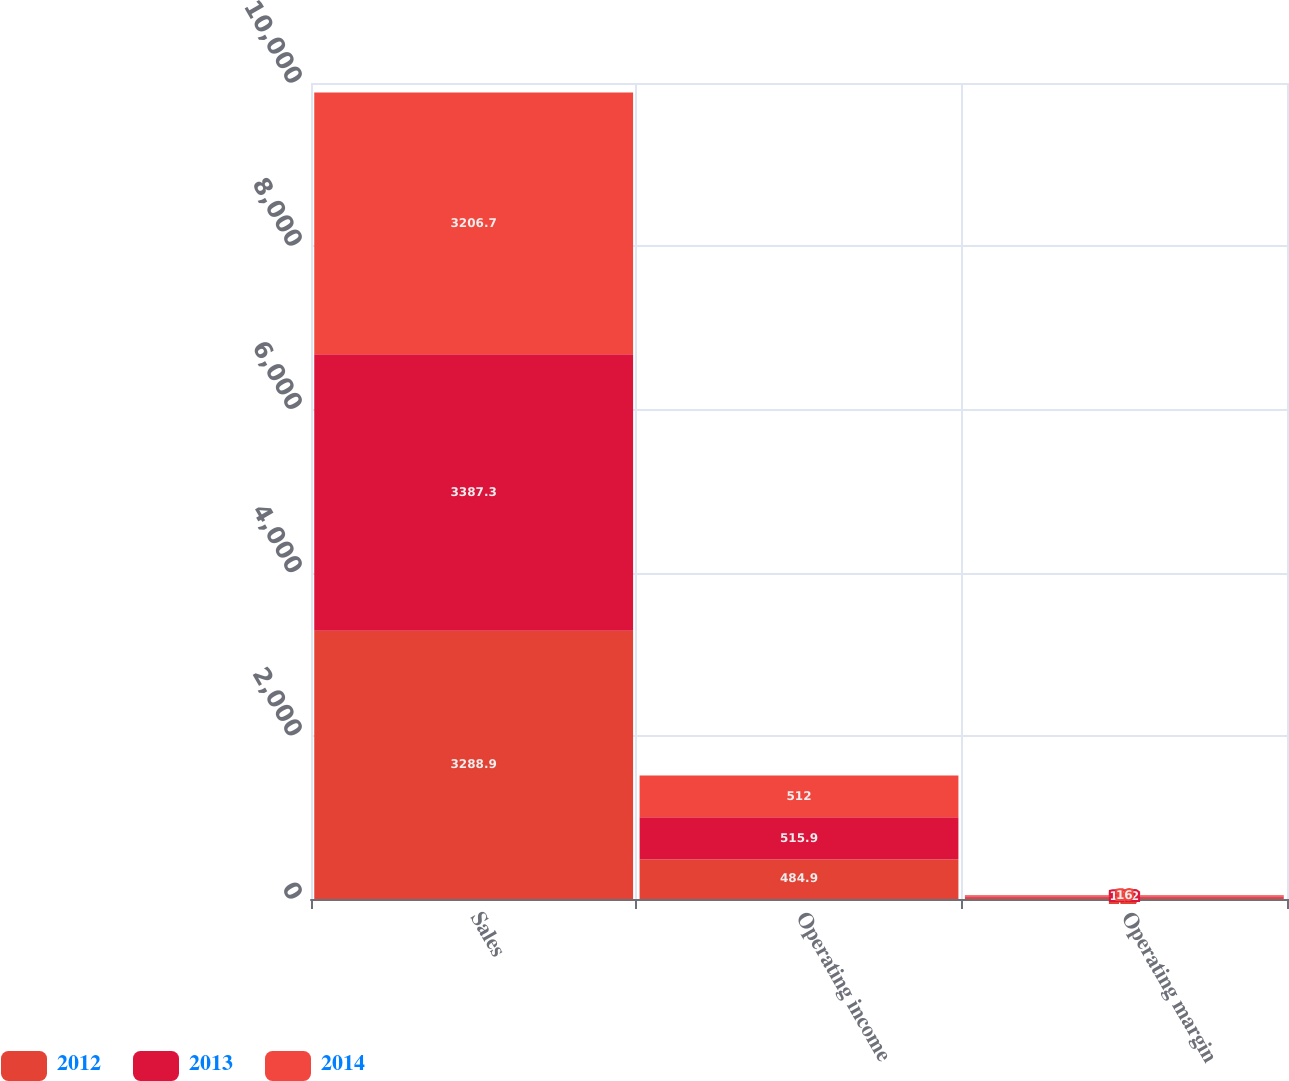Convert chart. <chart><loc_0><loc_0><loc_500><loc_500><stacked_bar_chart><ecel><fcel>Sales<fcel>Operating income<fcel>Operating margin<nl><fcel>2012<fcel>3288.9<fcel>484.9<fcel>14.7<nl><fcel>2013<fcel>3387.3<fcel>515.9<fcel>15.2<nl><fcel>2014<fcel>3206.7<fcel>512<fcel>16<nl></chart> 